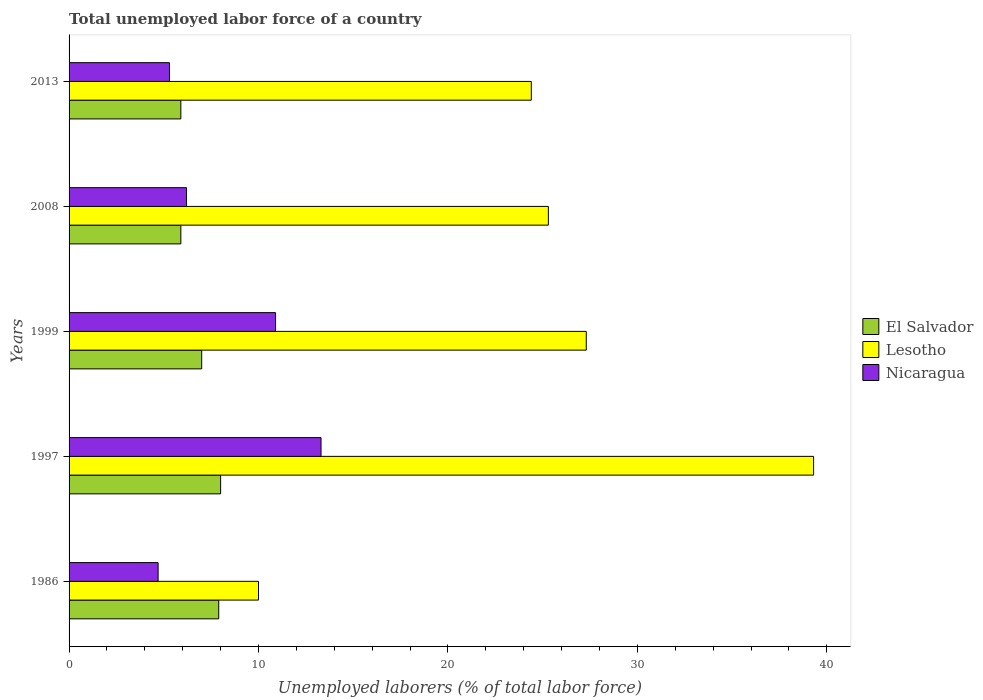How many different coloured bars are there?
Give a very brief answer. 3. How many groups of bars are there?
Ensure brevity in your answer.  5. How many bars are there on the 4th tick from the top?
Keep it short and to the point. 3. What is the total unemployed labor force in Lesotho in 2008?
Provide a succinct answer. 25.3. Across all years, what is the maximum total unemployed labor force in Lesotho?
Provide a short and direct response. 39.3. Across all years, what is the minimum total unemployed labor force in El Salvador?
Give a very brief answer. 5.9. In which year was the total unemployed labor force in Nicaragua maximum?
Provide a succinct answer. 1997. In which year was the total unemployed labor force in Nicaragua minimum?
Offer a very short reply. 1986. What is the total total unemployed labor force in Lesotho in the graph?
Your answer should be compact. 126.3. What is the difference between the total unemployed labor force in El Salvador in 1986 and that in 2013?
Offer a terse response. 2. What is the difference between the total unemployed labor force in Lesotho in 1997 and the total unemployed labor force in El Salvador in 2013?
Provide a short and direct response. 33.4. What is the average total unemployed labor force in Lesotho per year?
Offer a terse response. 25.26. In the year 2008, what is the difference between the total unemployed labor force in Nicaragua and total unemployed labor force in Lesotho?
Ensure brevity in your answer.  -19.1. In how many years, is the total unemployed labor force in El Salvador greater than 36 %?
Provide a short and direct response. 0. What is the ratio of the total unemployed labor force in Nicaragua in 1986 to that in 1997?
Your response must be concise. 0.35. Is the difference between the total unemployed labor force in Nicaragua in 1997 and 1999 greater than the difference between the total unemployed labor force in Lesotho in 1997 and 1999?
Ensure brevity in your answer.  No. What is the difference between the highest and the second highest total unemployed labor force in Nicaragua?
Your answer should be very brief. 2.4. What is the difference between the highest and the lowest total unemployed labor force in El Salvador?
Offer a very short reply. 2.1. In how many years, is the total unemployed labor force in Lesotho greater than the average total unemployed labor force in Lesotho taken over all years?
Offer a very short reply. 3. Is the sum of the total unemployed labor force in El Salvador in 1986 and 2008 greater than the maximum total unemployed labor force in Nicaragua across all years?
Offer a terse response. Yes. What does the 1st bar from the top in 1999 represents?
Make the answer very short. Nicaragua. What does the 2nd bar from the bottom in 1986 represents?
Your answer should be compact. Lesotho. Are all the bars in the graph horizontal?
Give a very brief answer. Yes. How many years are there in the graph?
Ensure brevity in your answer.  5. What is the difference between two consecutive major ticks on the X-axis?
Your response must be concise. 10. Are the values on the major ticks of X-axis written in scientific E-notation?
Provide a short and direct response. No. How many legend labels are there?
Your response must be concise. 3. How are the legend labels stacked?
Keep it short and to the point. Vertical. What is the title of the graph?
Give a very brief answer. Total unemployed labor force of a country. What is the label or title of the X-axis?
Provide a short and direct response. Unemployed laborers (% of total labor force). What is the Unemployed laborers (% of total labor force) of El Salvador in 1986?
Provide a short and direct response. 7.9. What is the Unemployed laborers (% of total labor force) in Nicaragua in 1986?
Keep it short and to the point. 4.7. What is the Unemployed laborers (% of total labor force) in Lesotho in 1997?
Make the answer very short. 39.3. What is the Unemployed laborers (% of total labor force) in Nicaragua in 1997?
Your answer should be compact. 13.3. What is the Unemployed laborers (% of total labor force) of Lesotho in 1999?
Your response must be concise. 27.3. What is the Unemployed laborers (% of total labor force) in Nicaragua in 1999?
Offer a very short reply. 10.9. What is the Unemployed laborers (% of total labor force) of El Salvador in 2008?
Your answer should be compact. 5.9. What is the Unemployed laborers (% of total labor force) in Lesotho in 2008?
Provide a succinct answer. 25.3. What is the Unemployed laborers (% of total labor force) in Nicaragua in 2008?
Give a very brief answer. 6.2. What is the Unemployed laborers (% of total labor force) in El Salvador in 2013?
Offer a very short reply. 5.9. What is the Unemployed laborers (% of total labor force) in Lesotho in 2013?
Provide a short and direct response. 24.4. What is the Unemployed laborers (% of total labor force) in Nicaragua in 2013?
Your response must be concise. 5.3. Across all years, what is the maximum Unemployed laborers (% of total labor force) of Lesotho?
Offer a very short reply. 39.3. Across all years, what is the maximum Unemployed laborers (% of total labor force) in Nicaragua?
Your response must be concise. 13.3. Across all years, what is the minimum Unemployed laborers (% of total labor force) of El Salvador?
Offer a very short reply. 5.9. Across all years, what is the minimum Unemployed laborers (% of total labor force) of Lesotho?
Give a very brief answer. 10. Across all years, what is the minimum Unemployed laborers (% of total labor force) in Nicaragua?
Keep it short and to the point. 4.7. What is the total Unemployed laborers (% of total labor force) in El Salvador in the graph?
Provide a short and direct response. 34.7. What is the total Unemployed laborers (% of total labor force) of Lesotho in the graph?
Your answer should be compact. 126.3. What is the total Unemployed laborers (% of total labor force) in Nicaragua in the graph?
Keep it short and to the point. 40.4. What is the difference between the Unemployed laborers (% of total labor force) of Lesotho in 1986 and that in 1997?
Your answer should be very brief. -29.3. What is the difference between the Unemployed laborers (% of total labor force) in Lesotho in 1986 and that in 1999?
Give a very brief answer. -17.3. What is the difference between the Unemployed laborers (% of total labor force) of Lesotho in 1986 and that in 2008?
Your answer should be very brief. -15.3. What is the difference between the Unemployed laborers (% of total labor force) in Lesotho in 1986 and that in 2013?
Keep it short and to the point. -14.4. What is the difference between the Unemployed laborers (% of total labor force) of El Salvador in 1997 and that in 1999?
Your response must be concise. 1. What is the difference between the Unemployed laborers (% of total labor force) of Lesotho in 1997 and that in 1999?
Offer a very short reply. 12. What is the difference between the Unemployed laborers (% of total labor force) of Nicaragua in 1997 and that in 2008?
Your answer should be very brief. 7.1. What is the difference between the Unemployed laborers (% of total labor force) of El Salvador in 1997 and that in 2013?
Provide a short and direct response. 2.1. What is the difference between the Unemployed laborers (% of total labor force) in Nicaragua in 1999 and that in 2008?
Offer a terse response. 4.7. What is the difference between the Unemployed laborers (% of total labor force) in El Salvador in 1999 and that in 2013?
Your response must be concise. 1.1. What is the difference between the Unemployed laborers (% of total labor force) of Lesotho in 2008 and that in 2013?
Give a very brief answer. 0.9. What is the difference between the Unemployed laborers (% of total labor force) of Nicaragua in 2008 and that in 2013?
Offer a terse response. 0.9. What is the difference between the Unemployed laborers (% of total labor force) in El Salvador in 1986 and the Unemployed laborers (% of total labor force) in Lesotho in 1997?
Your response must be concise. -31.4. What is the difference between the Unemployed laborers (% of total labor force) in Lesotho in 1986 and the Unemployed laborers (% of total labor force) in Nicaragua in 1997?
Provide a short and direct response. -3.3. What is the difference between the Unemployed laborers (% of total labor force) of El Salvador in 1986 and the Unemployed laborers (% of total labor force) of Lesotho in 1999?
Make the answer very short. -19.4. What is the difference between the Unemployed laborers (% of total labor force) in El Salvador in 1986 and the Unemployed laborers (% of total labor force) in Nicaragua in 1999?
Ensure brevity in your answer.  -3. What is the difference between the Unemployed laborers (% of total labor force) of El Salvador in 1986 and the Unemployed laborers (% of total labor force) of Lesotho in 2008?
Your response must be concise. -17.4. What is the difference between the Unemployed laborers (% of total labor force) of Lesotho in 1986 and the Unemployed laborers (% of total labor force) of Nicaragua in 2008?
Your answer should be very brief. 3.8. What is the difference between the Unemployed laborers (% of total labor force) of El Salvador in 1986 and the Unemployed laborers (% of total labor force) of Lesotho in 2013?
Offer a terse response. -16.5. What is the difference between the Unemployed laborers (% of total labor force) in El Salvador in 1986 and the Unemployed laborers (% of total labor force) in Nicaragua in 2013?
Provide a short and direct response. 2.6. What is the difference between the Unemployed laborers (% of total labor force) in El Salvador in 1997 and the Unemployed laborers (% of total labor force) in Lesotho in 1999?
Ensure brevity in your answer.  -19.3. What is the difference between the Unemployed laborers (% of total labor force) in El Salvador in 1997 and the Unemployed laborers (% of total labor force) in Nicaragua in 1999?
Offer a very short reply. -2.9. What is the difference between the Unemployed laborers (% of total labor force) in Lesotho in 1997 and the Unemployed laborers (% of total labor force) in Nicaragua in 1999?
Provide a succinct answer. 28.4. What is the difference between the Unemployed laborers (% of total labor force) of El Salvador in 1997 and the Unemployed laborers (% of total labor force) of Lesotho in 2008?
Offer a terse response. -17.3. What is the difference between the Unemployed laborers (% of total labor force) of Lesotho in 1997 and the Unemployed laborers (% of total labor force) of Nicaragua in 2008?
Your response must be concise. 33.1. What is the difference between the Unemployed laborers (% of total labor force) of El Salvador in 1997 and the Unemployed laborers (% of total labor force) of Lesotho in 2013?
Provide a succinct answer. -16.4. What is the difference between the Unemployed laborers (% of total labor force) of El Salvador in 1997 and the Unemployed laborers (% of total labor force) of Nicaragua in 2013?
Give a very brief answer. 2.7. What is the difference between the Unemployed laborers (% of total labor force) of El Salvador in 1999 and the Unemployed laborers (% of total labor force) of Lesotho in 2008?
Your answer should be compact. -18.3. What is the difference between the Unemployed laborers (% of total labor force) of Lesotho in 1999 and the Unemployed laborers (% of total labor force) of Nicaragua in 2008?
Provide a succinct answer. 21.1. What is the difference between the Unemployed laborers (% of total labor force) of El Salvador in 1999 and the Unemployed laborers (% of total labor force) of Lesotho in 2013?
Offer a very short reply. -17.4. What is the difference between the Unemployed laborers (% of total labor force) in El Salvador in 1999 and the Unemployed laborers (% of total labor force) in Nicaragua in 2013?
Provide a succinct answer. 1.7. What is the difference between the Unemployed laborers (% of total labor force) in Lesotho in 1999 and the Unemployed laborers (% of total labor force) in Nicaragua in 2013?
Provide a succinct answer. 22. What is the difference between the Unemployed laborers (% of total labor force) in El Salvador in 2008 and the Unemployed laborers (% of total labor force) in Lesotho in 2013?
Ensure brevity in your answer.  -18.5. What is the difference between the Unemployed laborers (% of total labor force) in El Salvador in 2008 and the Unemployed laborers (% of total labor force) in Nicaragua in 2013?
Your response must be concise. 0.6. What is the average Unemployed laborers (% of total labor force) of El Salvador per year?
Offer a terse response. 6.94. What is the average Unemployed laborers (% of total labor force) of Lesotho per year?
Offer a very short reply. 25.26. What is the average Unemployed laborers (% of total labor force) of Nicaragua per year?
Keep it short and to the point. 8.08. In the year 1986, what is the difference between the Unemployed laborers (% of total labor force) of El Salvador and Unemployed laborers (% of total labor force) of Lesotho?
Offer a very short reply. -2.1. In the year 1997, what is the difference between the Unemployed laborers (% of total labor force) of El Salvador and Unemployed laborers (% of total labor force) of Lesotho?
Offer a very short reply. -31.3. In the year 1999, what is the difference between the Unemployed laborers (% of total labor force) in El Salvador and Unemployed laborers (% of total labor force) in Lesotho?
Offer a very short reply. -20.3. In the year 1999, what is the difference between the Unemployed laborers (% of total labor force) of El Salvador and Unemployed laborers (% of total labor force) of Nicaragua?
Your response must be concise. -3.9. In the year 2008, what is the difference between the Unemployed laborers (% of total labor force) in El Salvador and Unemployed laborers (% of total labor force) in Lesotho?
Your answer should be compact. -19.4. In the year 2008, what is the difference between the Unemployed laborers (% of total labor force) in El Salvador and Unemployed laborers (% of total labor force) in Nicaragua?
Provide a succinct answer. -0.3. In the year 2008, what is the difference between the Unemployed laborers (% of total labor force) in Lesotho and Unemployed laborers (% of total labor force) in Nicaragua?
Provide a short and direct response. 19.1. In the year 2013, what is the difference between the Unemployed laborers (% of total labor force) of El Salvador and Unemployed laborers (% of total labor force) of Lesotho?
Offer a terse response. -18.5. In the year 2013, what is the difference between the Unemployed laborers (% of total labor force) in Lesotho and Unemployed laborers (% of total labor force) in Nicaragua?
Provide a succinct answer. 19.1. What is the ratio of the Unemployed laborers (% of total labor force) of El Salvador in 1986 to that in 1997?
Your response must be concise. 0.99. What is the ratio of the Unemployed laborers (% of total labor force) of Lesotho in 1986 to that in 1997?
Offer a very short reply. 0.25. What is the ratio of the Unemployed laborers (% of total labor force) of Nicaragua in 1986 to that in 1997?
Provide a succinct answer. 0.35. What is the ratio of the Unemployed laborers (% of total labor force) in El Salvador in 1986 to that in 1999?
Ensure brevity in your answer.  1.13. What is the ratio of the Unemployed laborers (% of total labor force) in Lesotho in 1986 to that in 1999?
Make the answer very short. 0.37. What is the ratio of the Unemployed laborers (% of total labor force) in Nicaragua in 1986 to that in 1999?
Provide a short and direct response. 0.43. What is the ratio of the Unemployed laborers (% of total labor force) in El Salvador in 1986 to that in 2008?
Your answer should be very brief. 1.34. What is the ratio of the Unemployed laborers (% of total labor force) in Lesotho in 1986 to that in 2008?
Make the answer very short. 0.4. What is the ratio of the Unemployed laborers (% of total labor force) in Nicaragua in 1986 to that in 2008?
Provide a succinct answer. 0.76. What is the ratio of the Unemployed laborers (% of total labor force) of El Salvador in 1986 to that in 2013?
Make the answer very short. 1.34. What is the ratio of the Unemployed laborers (% of total labor force) in Lesotho in 1986 to that in 2013?
Give a very brief answer. 0.41. What is the ratio of the Unemployed laborers (% of total labor force) of Nicaragua in 1986 to that in 2013?
Give a very brief answer. 0.89. What is the ratio of the Unemployed laborers (% of total labor force) of El Salvador in 1997 to that in 1999?
Keep it short and to the point. 1.14. What is the ratio of the Unemployed laborers (% of total labor force) of Lesotho in 1997 to that in 1999?
Keep it short and to the point. 1.44. What is the ratio of the Unemployed laborers (% of total labor force) of Nicaragua in 1997 to that in 1999?
Give a very brief answer. 1.22. What is the ratio of the Unemployed laborers (% of total labor force) of El Salvador in 1997 to that in 2008?
Make the answer very short. 1.36. What is the ratio of the Unemployed laborers (% of total labor force) of Lesotho in 1997 to that in 2008?
Provide a succinct answer. 1.55. What is the ratio of the Unemployed laborers (% of total labor force) in Nicaragua in 1997 to that in 2008?
Keep it short and to the point. 2.15. What is the ratio of the Unemployed laborers (% of total labor force) of El Salvador in 1997 to that in 2013?
Provide a short and direct response. 1.36. What is the ratio of the Unemployed laborers (% of total labor force) of Lesotho in 1997 to that in 2013?
Provide a succinct answer. 1.61. What is the ratio of the Unemployed laborers (% of total labor force) in Nicaragua in 1997 to that in 2013?
Provide a succinct answer. 2.51. What is the ratio of the Unemployed laborers (% of total labor force) of El Salvador in 1999 to that in 2008?
Your response must be concise. 1.19. What is the ratio of the Unemployed laborers (% of total labor force) in Lesotho in 1999 to that in 2008?
Make the answer very short. 1.08. What is the ratio of the Unemployed laborers (% of total labor force) in Nicaragua in 1999 to that in 2008?
Give a very brief answer. 1.76. What is the ratio of the Unemployed laborers (% of total labor force) of El Salvador in 1999 to that in 2013?
Your response must be concise. 1.19. What is the ratio of the Unemployed laborers (% of total labor force) in Lesotho in 1999 to that in 2013?
Offer a very short reply. 1.12. What is the ratio of the Unemployed laborers (% of total labor force) of Nicaragua in 1999 to that in 2013?
Your answer should be compact. 2.06. What is the ratio of the Unemployed laborers (% of total labor force) of El Salvador in 2008 to that in 2013?
Offer a very short reply. 1. What is the ratio of the Unemployed laborers (% of total labor force) of Lesotho in 2008 to that in 2013?
Your answer should be compact. 1.04. What is the ratio of the Unemployed laborers (% of total labor force) of Nicaragua in 2008 to that in 2013?
Your response must be concise. 1.17. What is the difference between the highest and the second highest Unemployed laborers (% of total labor force) of Lesotho?
Your answer should be compact. 12. What is the difference between the highest and the second highest Unemployed laborers (% of total labor force) of Nicaragua?
Provide a short and direct response. 2.4. What is the difference between the highest and the lowest Unemployed laborers (% of total labor force) in Lesotho?
Keep it short and to the point. 29.3. What is the difference between the highest and the lowest Unemployed laborers (% of total labor force) in Nicaragua?
Offer a very short reply. 8.6. 